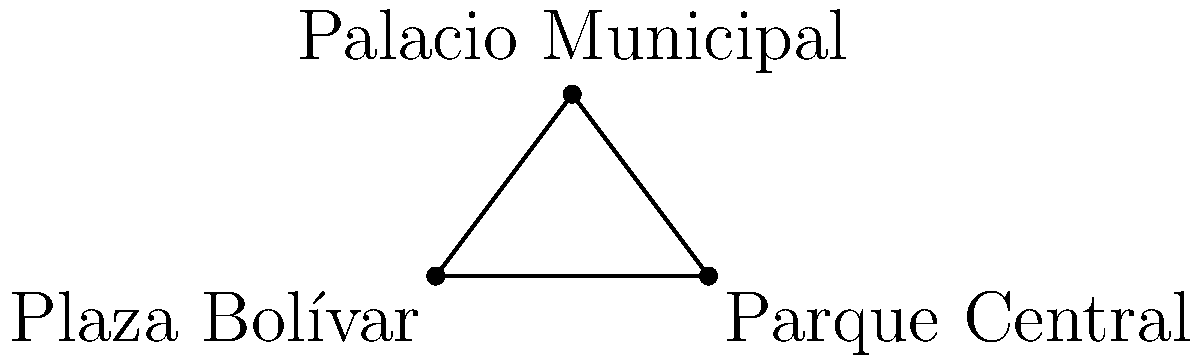In Guaranda, the capital of Bolívar province, three significant political landmarks form a triangular region: Plaza Bolívar at (0,0), Parque Central at (6,0), and Palacio Municipal at (3,4). Calculate the area of this triangular region in square units. To find the area of the triangular region, we can use the formula for the area of a triangle given the coordinates of its vertices:

Area = $\frac{1}{2}|x_1(y_2 - y_3) + x_2(y_3 - y_1) + x_3(y_1 - y_2)|$

Where $(x_1, y_1)$, $(x_2, y_2)$, and $(x_3, y_3)$ are the coordinates of the three vertices.

Let's assign the coordinates:
Plaza Bolívar: $(x_1, y_1) = (0, 0)$
Parque Central: $(x_2, y_2) = (6, 0)$
Palacio Municipal: $(x_3, y_3) = (3, 4)$

Now, let's substitute these into the formula:

Area = $\frac{1}{2}|0(0 - 4) + 6(4 - 0) + 3(0 - 0)|$

Simplifying:
Area = $\frac{1}{2}|0 + 24 + 0|$
Area = $\frac{1}{2}(24)$
Area = 12

Therefore, the area of the triangular region is 12 square units.
Answer: 12 square units 